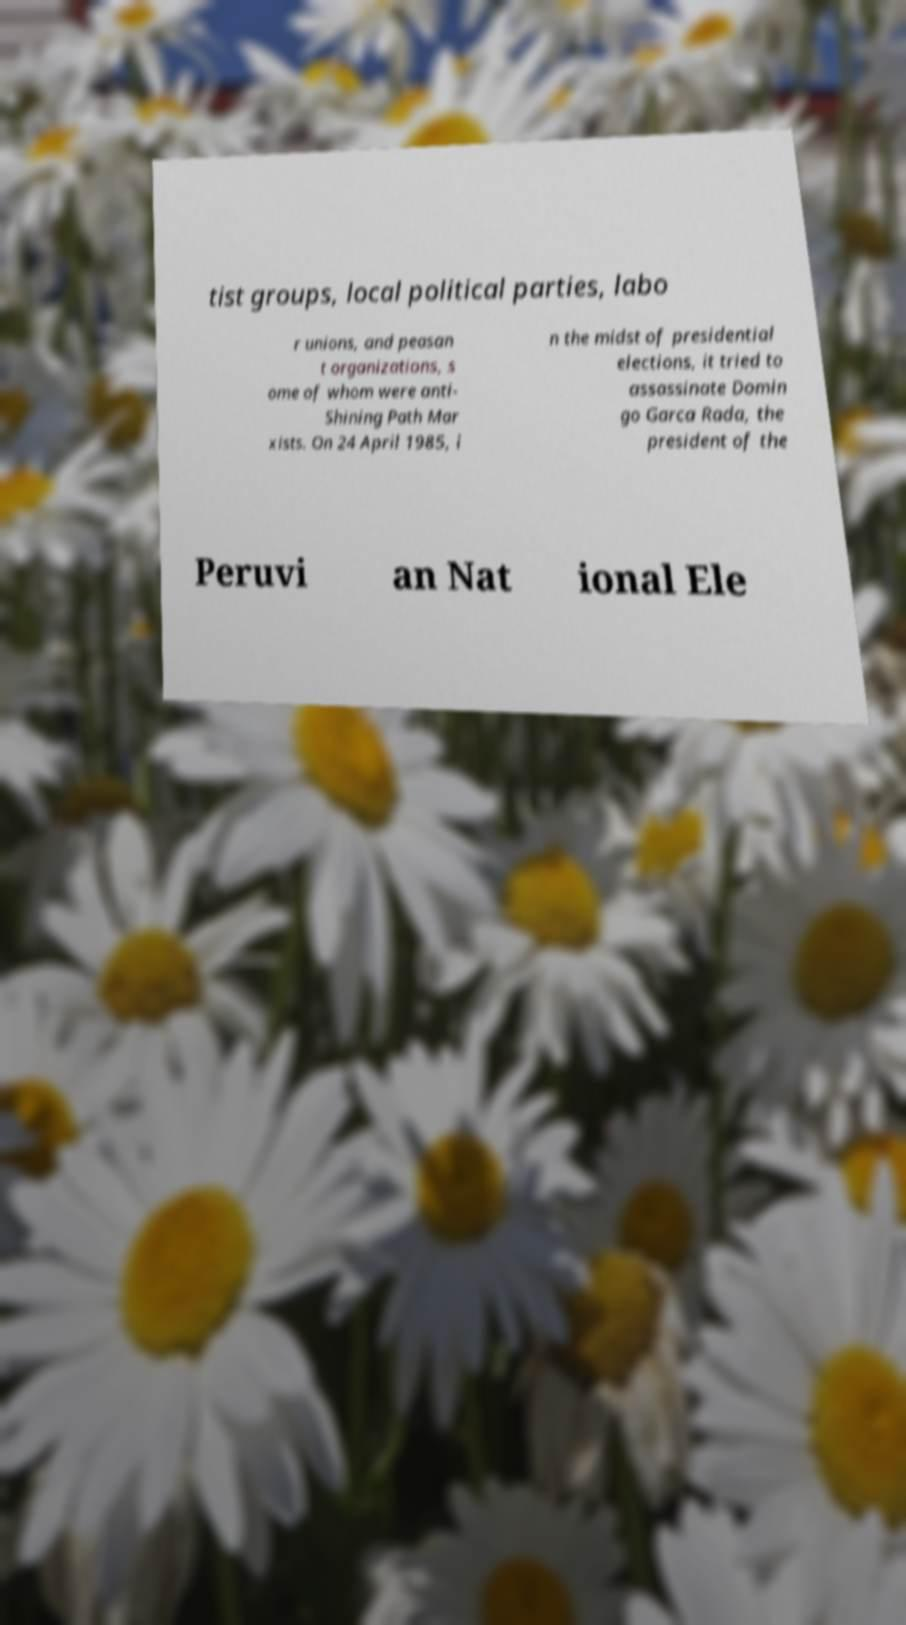Could you assist in decoding the text presented in this image and type it out clearly? tist groups, local political parties, labo r unions, and peasan t organizations, s ome of whom were anti- Shining Path Mar xists. On 24 April 1985, i n the midst of presidential elections, it tried to assassinate Domin go Garca Rada, the president of the Peruvi an Nat ional Ele 